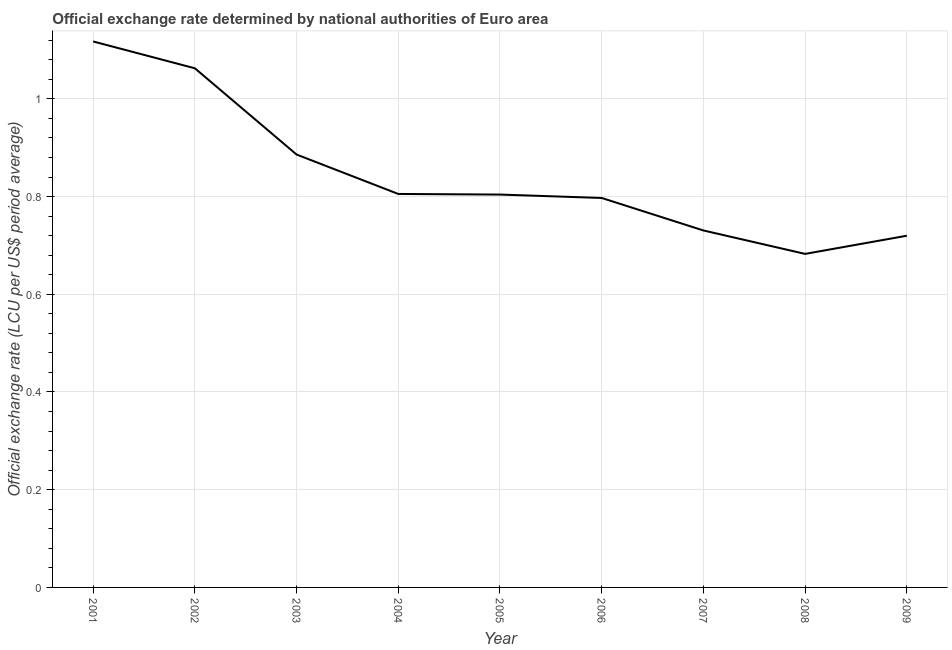What is the official exchange rate in 2005?
Offer a terse response. 0.8. Across all years, what is the maximum official exchange rate?
Offer a very short reply. 1.12. Across all years, what is the minimum official exchange rate?
Offer a very short reply. 0.68. In which year was the official exchange rate maximum?
Provide a succinct answer. 2001. In which year was the official exchange rate minimum?
Ensure brevity in your answer.  2008. What is the sum of the official exchange rate?
Your answer should be very brief. 7.61. What is the difference between the official exchange rate in 2002 and 2003?
Give a very brief answer. 0.18. What is the average official exchange rate per year?
Keep it short and to the point. 0.85. What is the median official exchange rate?
Offer a terse response. 0.8. In how many years, is the official exchange rate greater than 0.88 ?
Offer a terse response. 3. Do a majority of the years between 2001 and 2004 (inclusive) have official exchange rate greater than 0.68 ?
Make the answer very short. Yes. What is the ratio of the official exchange rate in 2007 to that in 2008?
Your response must be concise. 1.07. Is the official exchange rate in 2003 less than that in 2005?
Make the answer very short. No. What is the difference between the highest and the second highest official exchange rate?
Provide a succinct answer. 0.05. Is the sum of the official exchange rate in 2001 and 2004 greater than the maximum official exchange rate across all years?
Ensure brevity in your answer.  Yes. What is the difference between the highest and the lowest official exchange rate?
Give a very brief answer. 0.43. Does the official exchange rate monotonically increase over the years?
Give a very brief answer. No. How many years are there in the graph?
Give a very brief answer. 9. What is the title of the graph?
Offer a very short reply. Official exchange rate determined by national authorities of Euro area. What is the label or title of the X-axis?
Offer a very short reply. Year. What is the label or title of the Y-axis?
Your answer should be very brief. Official exchange rate (LCU per US$ period average). What is the Official exchange rate (LCU per US$ period average) in 2001?
Offer a very short reply. 1.12. What is the Official exchange rate (LCU per US$ period average) of 2002?
Your answer should be compact. 1.06. What is the Official exchange rate (LCU per US$ period average) in 2003?
Ensure brevity in your answer.  0.89. What is the Official exchange rate (LCU per US$ period average) in 2004?
Your response must be concise. 0.81. What is the Official exchange rate (LCU per US$ period average) in 2005?
Your answer should be compact. 0.8. What is the Official exchange rate (LCU per US$ period average) of 2006?
Make the answer very short. 0.8. What is the Official exchange rate (LCU per US$ period average) of 2007?
Provide a short and direct response. 0.73. What is the Official exchange rate (LCU per US$ period average) of 2008?
Offer a terse response. 0.68. What is the Official exchange rate (LCU per US$ period average) of 2009?
Ensure brevity in your answer.  0.72. What is the difference between the Official exchange rate (LCU per US$ period average) in 2001 and 2002?
Keep it short and to the point. 0.05. What is the difference between the Official exchange rate (LCU per US$ period average) in 2001 and 2003?
Provide a short and direct response. 0.23. What is the difference between the Official exchange rate (LCU per US$ period average) in 2001 and 2004?
Give a very brief answer. 0.31. What is the difference between the Official exchange rate (LCU per US$ period average) in 2001 and 2005?
Your answer should be compact. 0.31. What is the difference between the Official exchange rate (LCU per US$ period average) in 2001 and 2006?
Make the answer very short. 0.32. What is the difference between the Official exchange rate (LCU per US$ period average) in 2001 and 2007?
Your answer should be compact. 0.39. What is the difference between the Official exchange rate (LCU per US$ period average) in 2001 and 2008?
Your answer should be compact. 0.43. What is the difference between the Official exchange rate (LCU per US$ period average) in 2001 and 2009?
Your answer should be very brief. 0.4. What is the difference between the Official exchange rate (LCU per US$ period average) in 2002 and 2003?
Give a very brief answer. 0.18. What is the difference between the Official exchange rate (LCU per US$ period average) in 2002 and 2004?
Offer a terse response. 0.26. What is the difference between the Official exchange rate (LCU per US$ period average) in 2002 and 2005?
Your answer should be very brief. 0.26. What is the difference between the Official exchange rate (LCU per US$ period average) in 2002 and 2006?
Keep it short and to the point. 0.27. What is the difference between the Official exchange rate (LCU per US$ period average) in 2002 and 2007?
Give a very brief answer. 0.33. What is the difference between the Official exchange rate (LCU per US$ period average) in 2002 and 2008?
Offer a terse response. 0.38. What is the difference between the Official exchange rate (LCU per US$ period average) in 2002 and 2009?
Keep it short and to the point. 0.34. What is the difference between the Official exchange rate (LCU per US$ period average) in 2003 and 2004?
Make the answer very short. 0.08. What is the difference between the Official exchange rate (LCU per US$ period average) in 2003 and 2005?
Give a very brief answer. 0.08. What is the difference between the Official exchange rate (LCU per US$ period average) in 2003 and 2006?
Provide a succinct answer. 0.09. What is the difference between the Official exchange rate (LCU per US$ period average) in 2003 and 2007?
Offer a terse response. 0.16. What is the difference between the Official exchange rate (LCU per US$ period average) in 2003 and 2008?
Ensure brevity in your answer.  0.2. What is the difference between the Official exchange rate (LCU per US$ period average) in 2003 and 2009?
Your answer should be very brief. 0.17. What is the difference between the Official exchange rate (LCU per US$ period average) in 2004 and 2005?
Offer a terse response. 0. What is the difference between the Official exchange rate (LCU per US$ period average) in 2004 and 2006?
Your response must be concise. 0.01. What is the difference between the Official exchange rate (LCU per US$ period average) in 2004 and 2007?
Your answer should be compact. 0.07. What is the difference between the Official exchange rate (LCU per US$ period average) in 2004 and 2008?
Make the answer very short. 0.12. What is the difference between the Official exchange rate (LCU per US$ period average) in 2004 and 2009?
Offer a terse response. 0.09. What is the difference between the Official exchange rate (LCU per US$ period average) in 2005 and 2006?
Your response must be concise. 0.01. What is the difference between the Official exchange rate (LCU per US$ period average) in 2005 and 2007?
Ensure brevity in your answer.  0.07. What is the difference between the Official exchange rate (LCU per US$ period average) in 2005 and 2008?
Your answer should be very brief. 0.12. What is the difference between the Official exchange rate (LCU per US$ period average) in 2005 and 2009?
Keep it short and to the point. 0.08. What is the difference between the Official exchange rate (LCU per US$ period average) in 2006 and 2007?
Provide a short and direct response. 0.07. What is the difference between the Official exchange rate (LCU per US$ period average) in 2006 and 2008?
Your answer should be compact. 0.11. What is the difference between the Official exchange rate (LCU per US$ period average) in 2006 and 2009?
Keep it short and to the point. 0.08. What is the difference between the Official exchange rate (LCU per US$ period average) in 2007 and 2008?
Provide a succinct answer. 0.05. What is the difference between the Official exchange rate (LCU per US$ period average) in 2007 and 2009?
Provide a short and direct response. 0.01. What is the difference between the Official exchange rate (LCU per US$ period average) in 2008 and 2009?
Give a very brief answer. -0.04. What is the ratio of the Official exchange rate (LCU per US$ period average) in 2001 to that in 2002?
Your response must be concise. 1.05. What is the ratio of the Official exchange rate (LCU per US$ period average) in 2001 to that in 2003?
Make the answer very short. 1.26. What is the ratio of the Official exchange rate (LCU per US$ period average) in 2001 to that in 2004?
Offer a terse response. 1.39. What is the ratio of the Official exchange rate (LCU per US$ period average) in 2001 to that in 2005?
Your answer should be compact. 1.39. What is the ratio of the Official exchange rate (LCU per US$ period average) in 2001 to that in 2006?
Provide a succinct answer. 1.4. What is the ratio of the Official exchange rate (LCU per US$ period average) in 2001 to that in 2007?
Offer a terse response. 1.53. What is the ratio of the Official exchange rate (LCU per US$ period average) in 2001 to that in 2008?
Give a very brief answer. 1.64. What is the ratio of the Official exchange rate (LCU per US$ period average) in 2001 to that in 2009?
Offer a terse response. 1.55. What is the ratio of the Official exchange rate (LCU per US$ period average) in 2002 to that in 2003?
Your answer should be very brief. 1.2. What is the ratio of the Official exchange rate (LCU per US$ period average) in 2002 to that in 2004?
Make the answer very short. 1.32. What is the ratio of the Official exchange rate (LCU per US$ period average) in 2002 to that in 2005?
Ensure brevity in your answer.  1.32. What is the ratio of the Official exchange rate (LCU per US$ period average) in 2002 to that in 2006?
Your answer should be compact. 1.33. What is the ratio of the Official exchange rate (LCU per US$ period average) in 2002 to that in 2007?
Offer a terse response. 1.45. What is the ratio of the Official exchange rate (LCU per US$ period average) in 2002 to that in 2008?
Provide a succinct answer. 1.56. What is the ratio of the Official exchange rate (LCU per US$ period average) in 2002 to that in 2009?
Provide a succinct answer. 1.48. What is the ratio of the Official exchange rate (LCU per US$ period average) in 2003 to that in 2004?
Your answer should be compact. 1.1. What is the ratio of the Official exchange rate (LCU per US$ period average) in 2003 to that in 2005?
Your answer should be compact. 1.1. What is the ratio of the Official exchange rate (LCU per US$ period average) in 2003 to that in 2006?
Provide a short and direct response. 1.11. What is the ratio of the Official exchange rate (LCU per US$ period average) in 2003 to that in 2007?
Provide a succinct answer. 1.21. What is the ratio of the Official exchange rate (LCU per US$ period average) in 2003 to that in 2008?
Give a very brief answer. 1.3. What is the ratio of the Official exchange rate (LCU per US$ period average) in 2003 to that in 2009?
Your answer should be compact. 1.23. What is the ratio of the Official exchange rate (LCU per US$ period average) in 2004 to that in 2005?
Keep it short and to the point. 1. What is the ratio of the Official exchange rate (LCU per US$ period average) in 2004 to that in 2006?
Your answer should be compact. 1.01. What is the ratio of the Official exchange rate (LCU per US$ period average) in 2004 to that in 2007?
Offer a very short reply. 1.1. What is the ratio of the Official exchange rate (LCU per US$ period average) in 2004 to that in 2008?
Keep it short and to the point. 1.18. What is the ratio of the Official exchange rate (LCU per US$ period average) in 2004 to that in 2009?
Provide a short and direct response. 1.12. What is the ratio of the Official exchange rate (LCU per US$ period average) in 2005 to that in 2007?
Keep it short and to the point. 1.1. What is the ratio of the Official exchange rate (LCU per US$ period average) in 2005 to that in 2008?
Provide a short and direct response. 1.18. What is the ratio of the Official exchange rate (LCU per US$ period average) in 2005 to that in 2009?
Keep it short and to the point. 1.12. What is the ratio of the Official exchange rate (LCU per US$ period average) in 2006 to that in 2007?
Provide a short and direct response. 1.09. What is the ratio of the Official exchange rate (LCU per US$ period average) in 2006 to that in 2008?
Offer a terse response. 1.17. What is the ratio of the Official exchange rate (LCU per US$ period average) in 2006 to that in 2009?
Your answer should be very brief. 1.11. What is the ratio of the Official exchange rate (LCU per US$ period average) in 2007 to that in 2008?
Offer a very short reply. 1.07. What is the ratio of the Official exchange rate (LCU per US$ period average) in 2008 to that in 2009?
Your response must be concise. 0.95. 